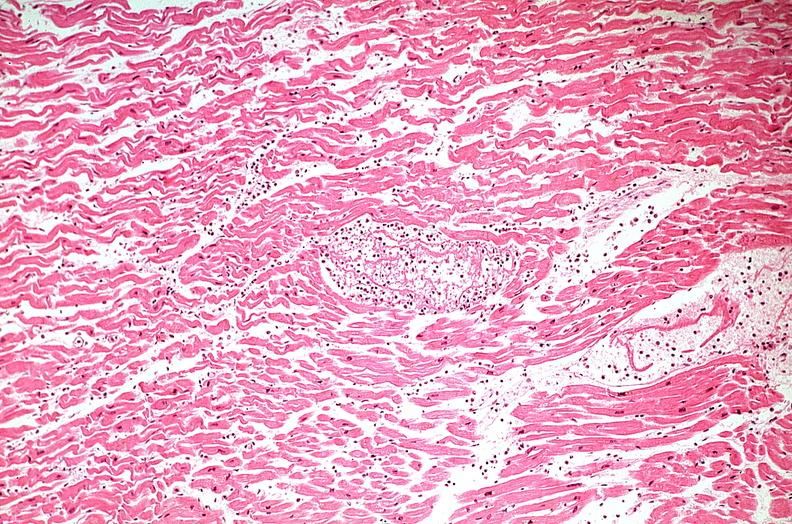what does this image show?
Answer the question using a single word or phrase. Heart 